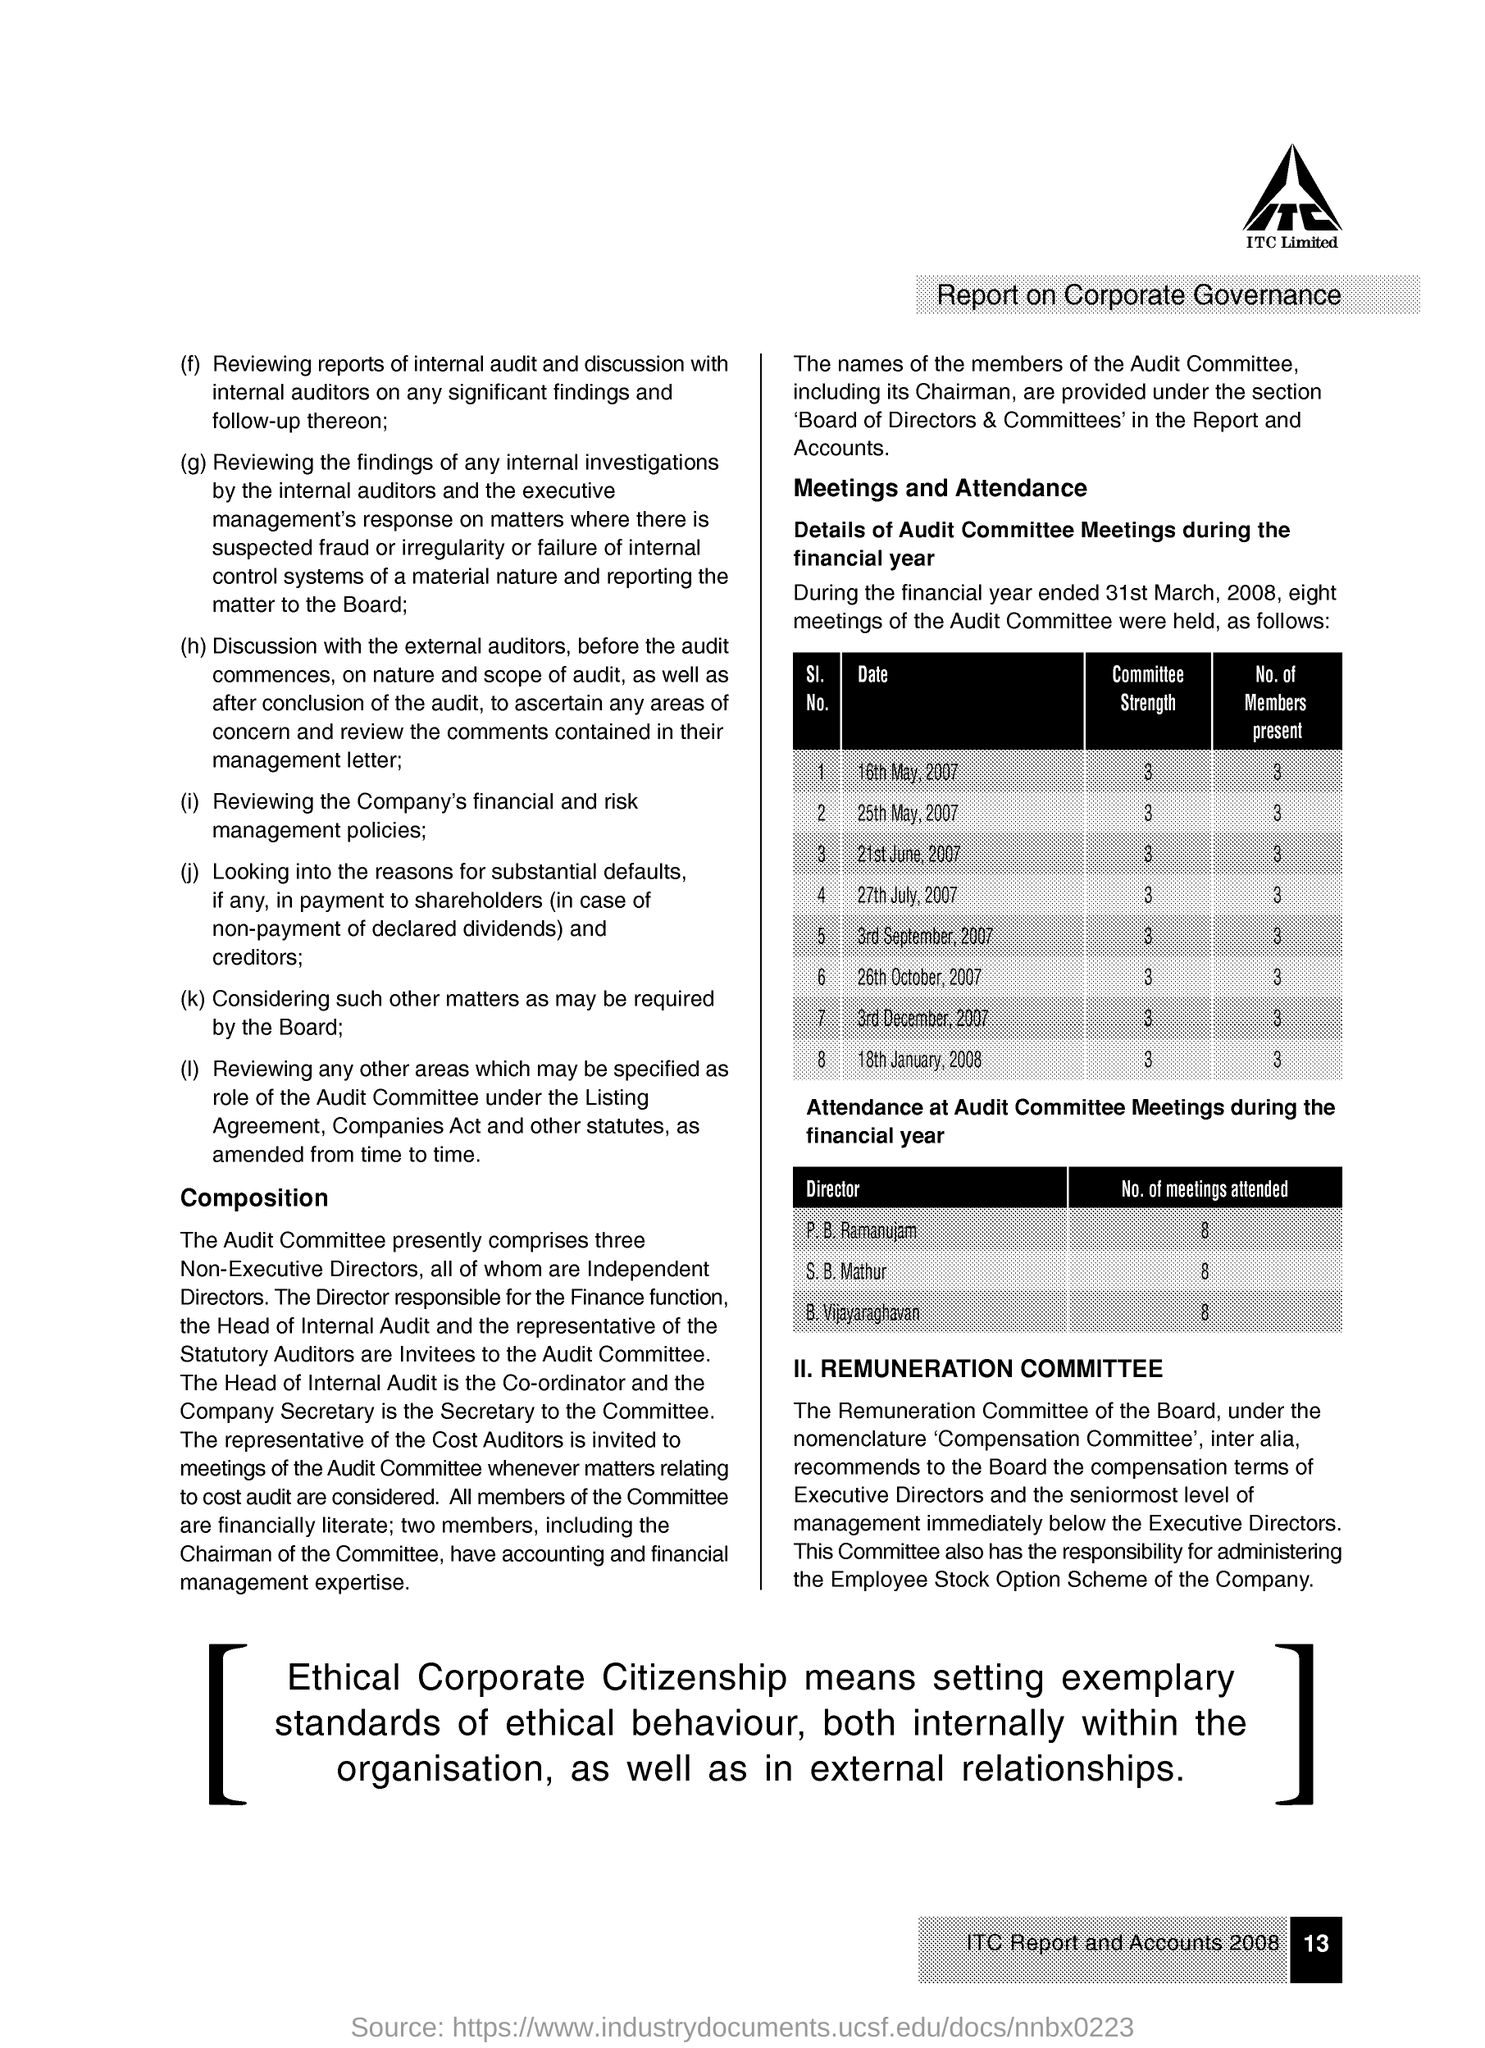What is this document reported on ?
Your answer should be compact. Report on Corporate Governance. How many of meeting did S. B. Mathur attended ?
Provide a short and direct response. 8. How many members were present at the meeting dated on 3rd September, 2007
Your response must be concise. 3. What is the Committee Strength of the meeting dated on 16th May, 2007 ?
Your answer should be very brief. 3. 